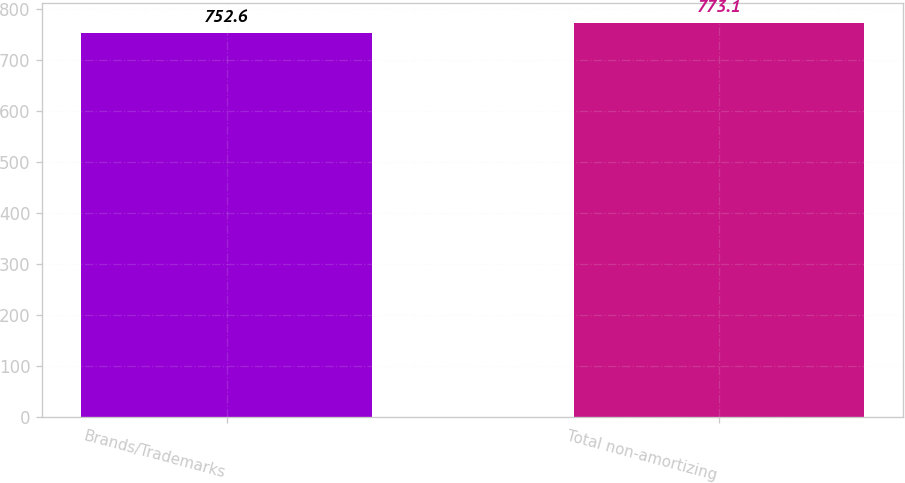<chart> <loc_0><loc_0><loc_500><loc_500><bar_chart><fcel>Brands/Trademarks<fcel>Total non-amortizing<nl><fcel>752.6<fcel>773.1<nl></chart> 